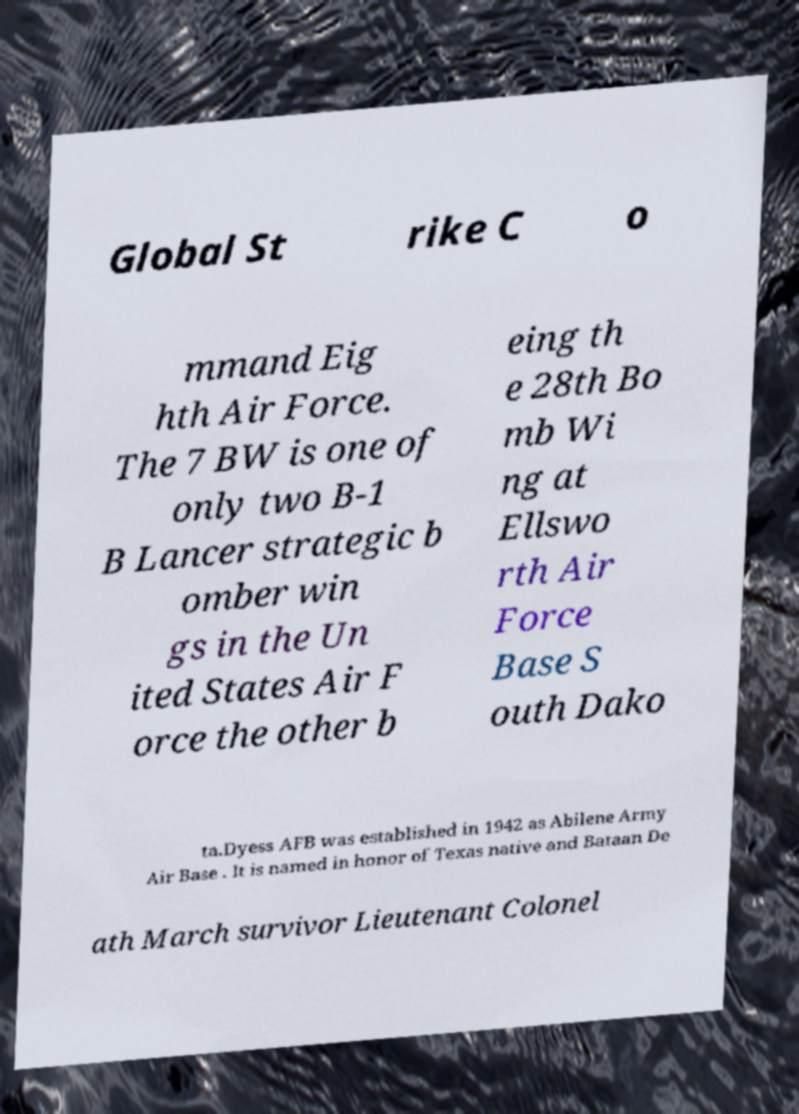Can you accurately transcribe the text from the provided image for me? Global St rike C o mmand Eig hth Air Force. The 7 BW is one of only two B-1 B Lancer strategic b omber win gs in the Un ited States Air F orce the other b eing th e 28th Bo mb Wi ng at Ellswo rth Air Force Base S outh Dako ta.Dyess AFB was established in 1942 as Abilene Army Air Base . It is named in honor of Texas native and Bataan De ath March survivor Lieutenant Colonel 